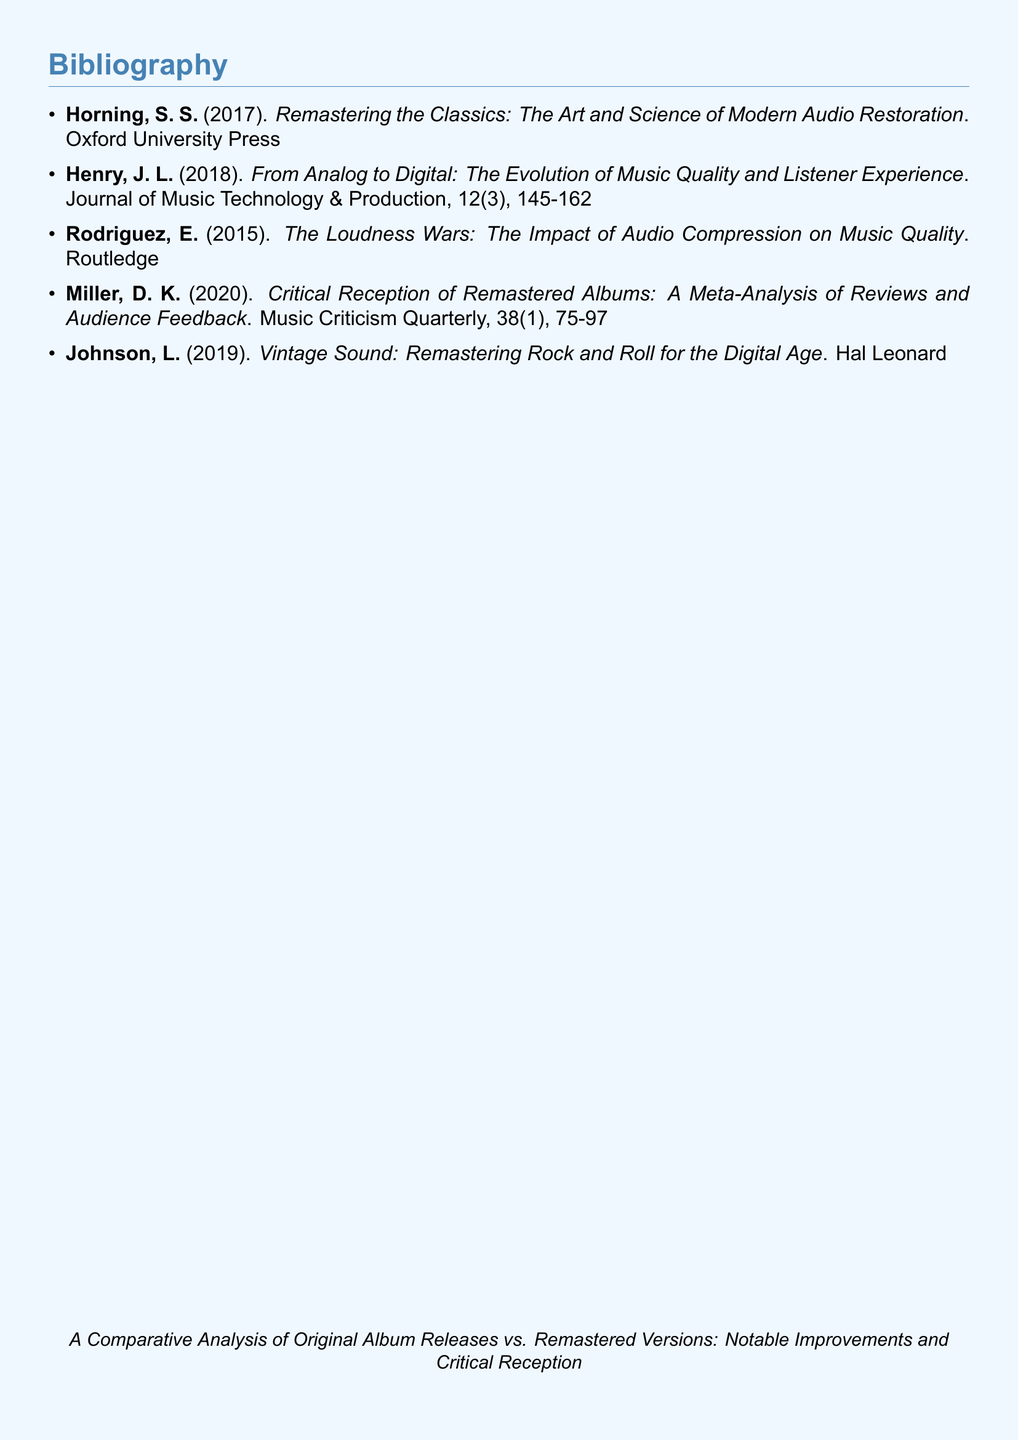What is the title of the first entry? The title of the first entry is found in the citation of the entry by Horning, which is "Remastering the Classics: The Art and Science of Modern Audio Restoration."
Answer: Remastering the Classics: The Art and Science of Modern Audio Restoration Who is the author of the second entry? The author of the second entry is indicated in the citation as Henry, J. L.
Answer: Henry, J. L In what year was "The Loudness Wars" published? The publication year of "The Loudness Wars" by Rodriguez is noted in the citation as 2015.
Answer: 2015 What is the main theme of the document? The main theme is expressed in the title at the bottom of the document, which is "A Comparative Analysis of Original Album Releases vs. Remastered Versions: Notable Improvements and Critical Reception."
Answer: A Comparative Analysis of Original Album Releases vs. Remastered Versions: Notable Improvements and Critical Reception How many entries are listed in the bibliography? The number of entries can be counted from the list, which shows a total of five entries provided.
Answer: 5 What type of publication is the second entry classified as? The second entry is published in a journal, as indicated by "Journal of Music Technology & Production."
Answer: Journal What is the main focus of Miller's article? The main focus of the article is described in the title, which emphasizes "Critical Reception of Remastered Albums."
Answer: Critical Reception of Remastered Albums Which publisher is associated with the book written by Johnson? The publisher associated with Johnson's book is "Hal Leonard," as indicated in the citation.
Answer: Hal Leonard 